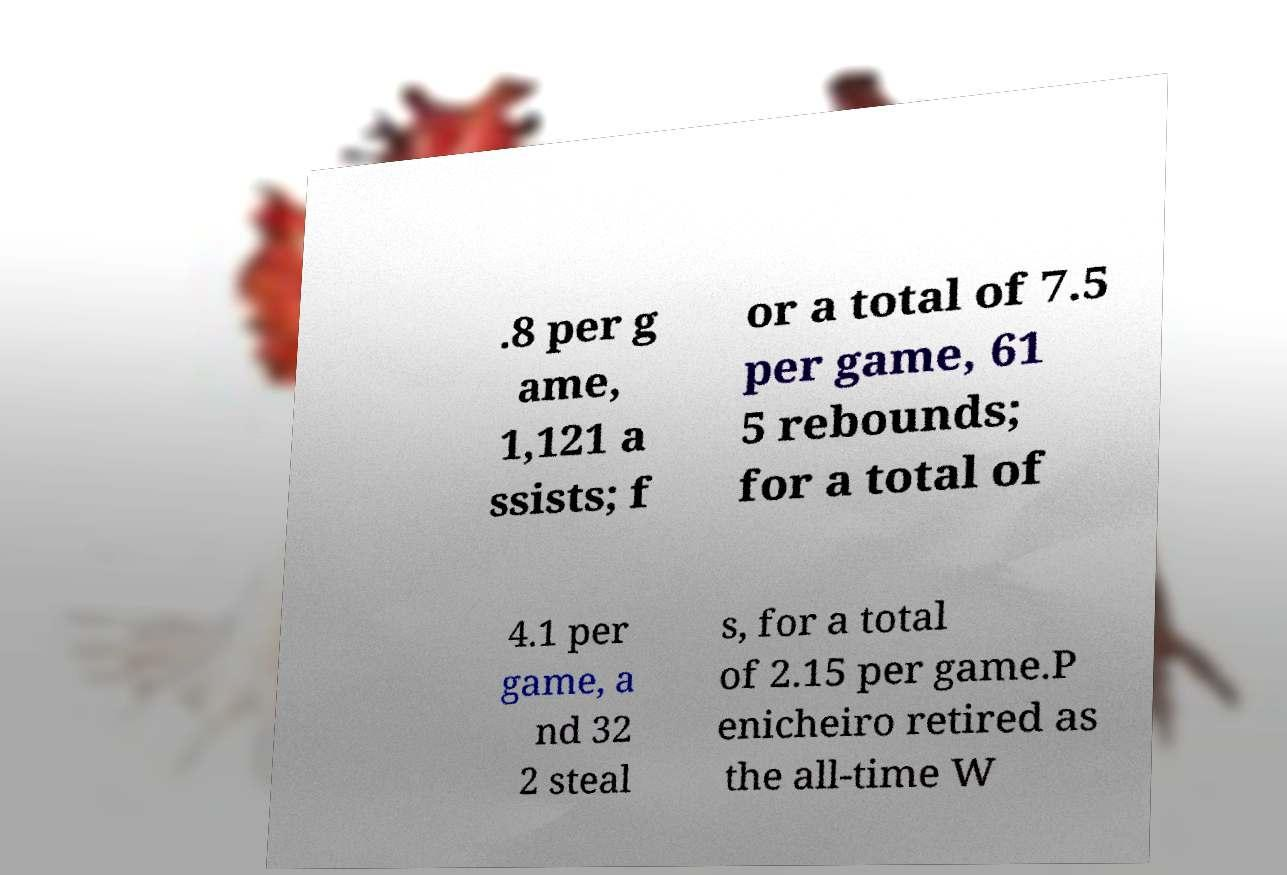Please read and relay the text visible in this image. What does it say? .8 per g ame, 1,121 a ssists; f or a total of 7.5 per game, 61 5 rebounds; for a total of 4.1 per game, a nd 32 2 steal s, for a total of 2.15 per game.P enicheiro retired as the all-time W 